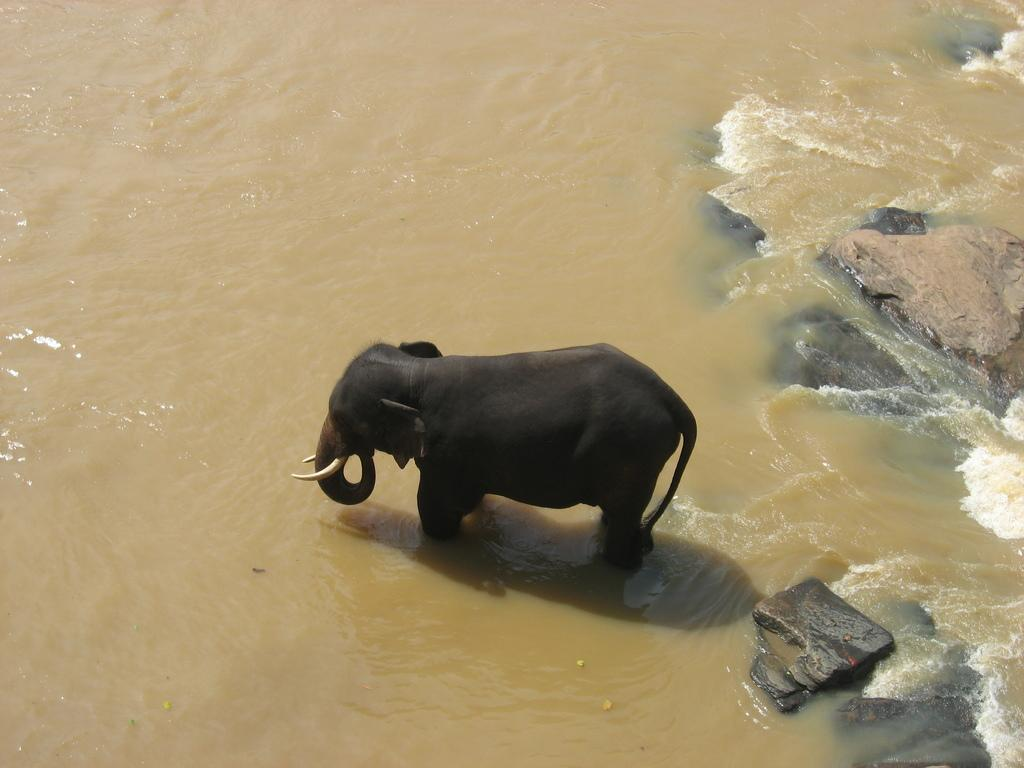What is the main subject in the center of the image? There is an elephant in the center of the image. What can be seen at the bottom of the image? There is water at the bottom of the image. What other objects are visible in the image? There are rocks visible in the image. What type of offer is the elephant making in the image? There is no offer being made in the image, as it features an elephant, water, and rocks. 